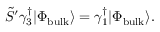Convert formula to latex. <formula><loc_0><loc_0><loc_500><loc_500>\tilde { S } ^ { \prime } \gamma _ { 3 } ^ { \dagger } | \Phi _ { b u l k } \rangle = \gamma _ { 1 } ^ { \dagger } | \Phi _ { b u l k } \rangle .</formula> 